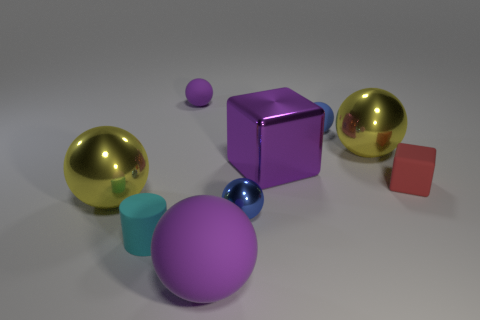Is there any other thing that has the same shape as the cyan matte object?
Give a very brief answer. No. There is a thing on the left side of the small cylinder; is it the same color as the large metallic sphere that is on the right side of the cylinder?
Ensure brevity in your answer.  Yes. What material is the large yellow thing in front of the yellow metal ball that is behind the yellow object in front of the red cube?
Give a very brief answer. Metal. Is there a rubber sphere of the same size as the matte cylinder?
Ensure brevity in your answer.  Yes. There is another blue ball that is the same size as the blue matte sphere; what material is it?
Give a very brief answer. Metal. There is a small blue thing that is in front of the tiny red rubber object; what is its shape?
Offer a very short reply. Sphere. Do the large object on the right side of the tiny blue matte sphere and the purple thing in front of the small cylinder have the same material?
Offer a terse response. No. How many large yellow things are the same shape as the blue metallic thing?
Give a very brief answer. 2. What is the material of the other big thing that is the same color as the large matte object?
Provide a succinct answer. Metal. How many objects are large metal blocks or yellow spheres that are in front of the red rubber object?
Ensure brevity in your answer.  2. 